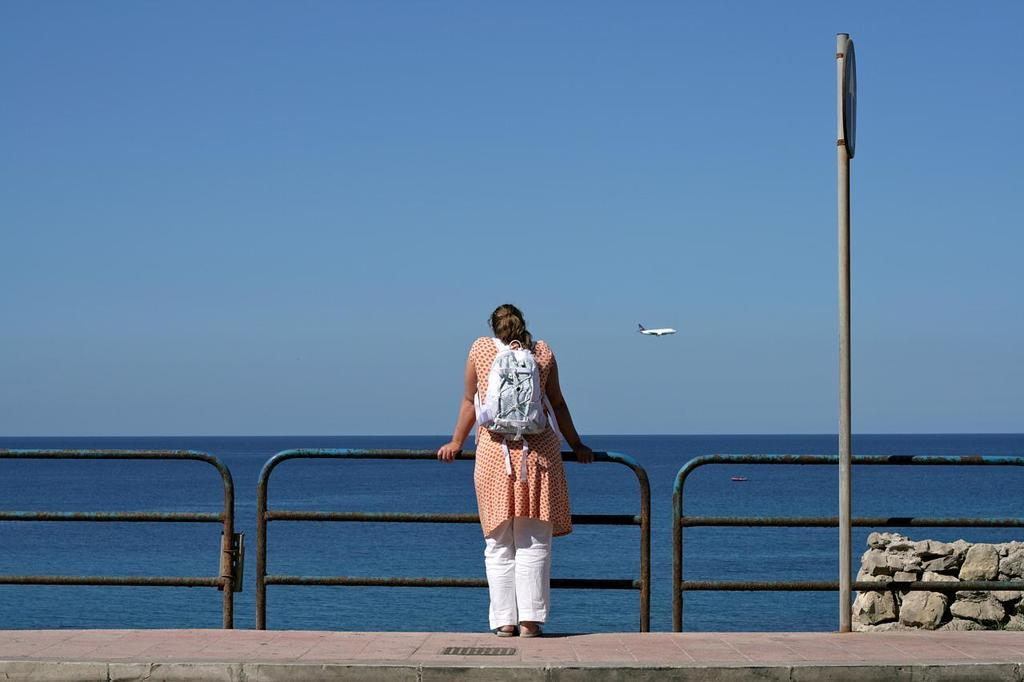What is the woman doing in the image? The woman is standing on the road in the image. What can be seen in the background of the image? There is water, an airplane, and the sky visible in the background of the image. Where is the sign board located in the image? The sign board is on the right side of the image. What type of weight is the woman lifting in the image? There is no weight visible in the image; the woman is simply standing on the road. 